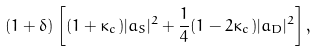<formula> <loc_0><loc_0><loc_500><loc_500>( 1 + \delta ) \left [ ( 1 + \kappa _ { c } ) | a _ { S } | ^ { 2 } + \frac { 1 } { 4 } ( 1 - 2 \kappa _ { c } ) | a _ { D } | ^ { 2 } \right ] ,</formula> 